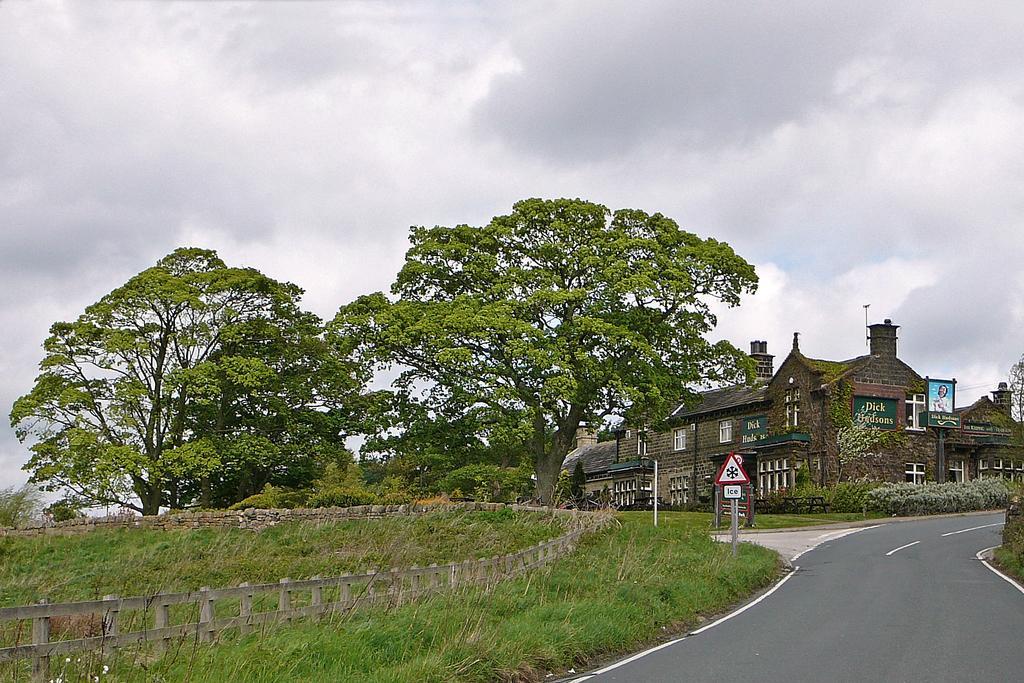Describe this image in one or two sentences. Bottom left side of the image there is fencing. Behind the fencing there is grass. Bottom right side of the image there is road. In the middle of the image there is pole and sign board. Behind the pole there are some trees and plants and buildings. Top of the image there are some clouds and sky. 